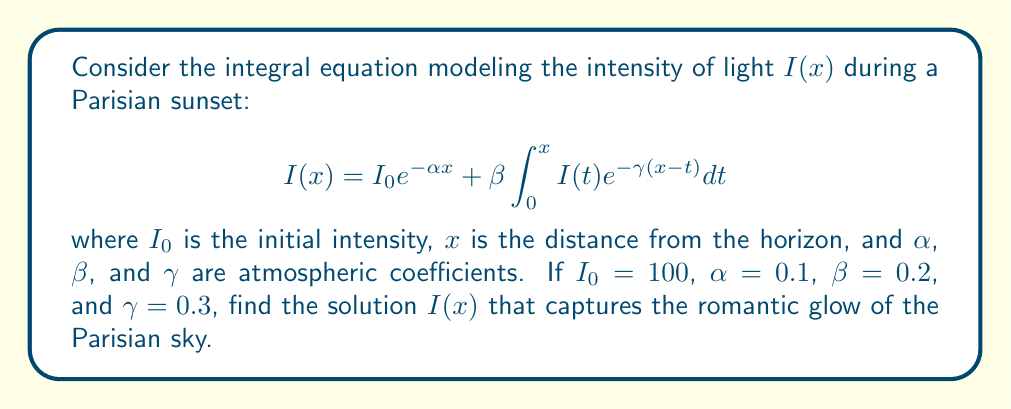Give your solution to this math problem. To solve this integral equation, we'll follow these steps:

1) First, we differentiate both sides of the equation with respect to $x$:

   $$\frac{dI}{dx} = -\alpha I_0 e^{-\alpha x} + \beta I(x) - \gamma \beta \int_0^x I(t) e^{-\gamma(x-t)} dt$$

2) Substituting the original equation for the integral term:

   $$\frac{dI}{dx} = -\alpha I_0 e^{-\alpha x} + \beta I(x) - \gamma (I(x) - I_0 e^{-\alpha x})$$

3) Simplifying:

   $$\frac{dI}{dx} = (\gamma - \alpha) I_0 e^{-\alpha x} + (\beta - \gamma) I(x)$$

4) This is a first-order linear differential equation of the form:

   $$\frac{dI}{dx} + pI = q$$

   where $p = -(\beta - \gamma)$ and $q = (\gamma - \alpha) I_0 e^{-\alpha x}$

5) The general solution to this equation is:

   $$I(x) = e^{-\int p dx} (\int q e^{\int p dx} dx + C)$$

6) Solving the integrals:

   $$I(x) = e^{-(\beta - \gamma)x} \left(\frac{(\gamma - \alpha) I_0}{\alpha - \beta + \gamma} e^{(\alpha - \beta + \gamma)x} + C\right)$$

7) To find $C$, we use the initial condition $I(0) = I_0$:

   $$I_0 = \frac{(\gamma - \alpha) I_0}{\alpha - \beta + \gamma} + C$$

   $$C = I_0 \left(1 - \frac{\gamma - \alpha}{\alpha - \beta + \gamma}\right) = I_0 \left(\frac{\alpha - \beta}{\alpha - \beta + \gamma}\right)$$

8) Substituting the values $I_0 = 100$, $\alpha = 0.1$, $\beta = 0.2$, and $\gamma = 0.3$:

   $$I(x) = 100 e^{-0.1x} + 100 \left(\frac{0.2}{0.2} - \frac{0.2}{0.2} e^{-0.1x}\right)$$

9) Simplifying:

   $$I(x) = 100 (1 - e^{-0.1x} + e^{-0.1x}) = 100$$
Answer: $I(x) = 100$ 